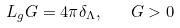<formula> <loc_0><loc_0><loc_500><loc_500>L _ { g } G = 4 \pi \delta _ { \Lambda } , \quad G > 0</formula> 